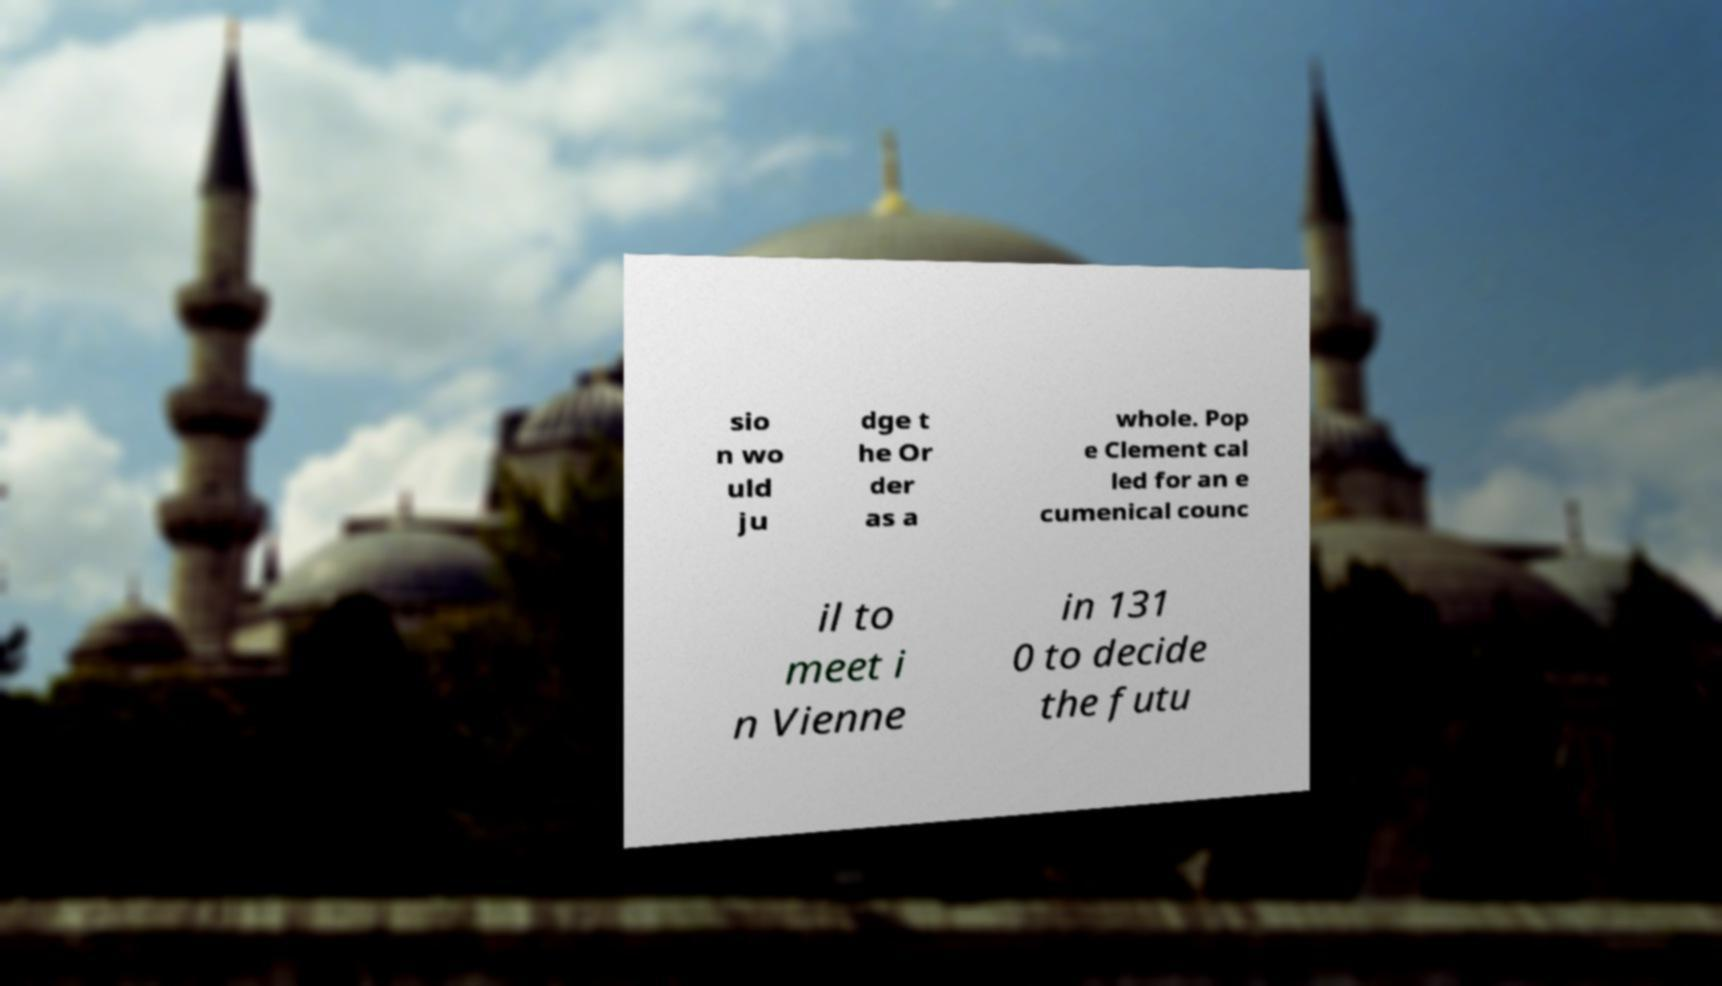Can you read and provide the text displayed in the image?This photo seems to have some interesting text. Can you extract and type it out for me? sio n wo uld ju dge t he Or der as a whole. Pop e Clement cal led for an e cumenical counc il to meet i n Vienne in 131 0 to decide the futu 